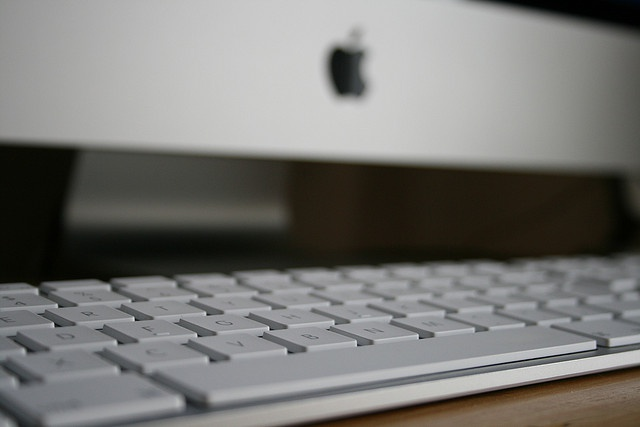Describe the objects in this image and their specific colors. I can see a keyboard in gray, darkgray, and black tones in this image. 